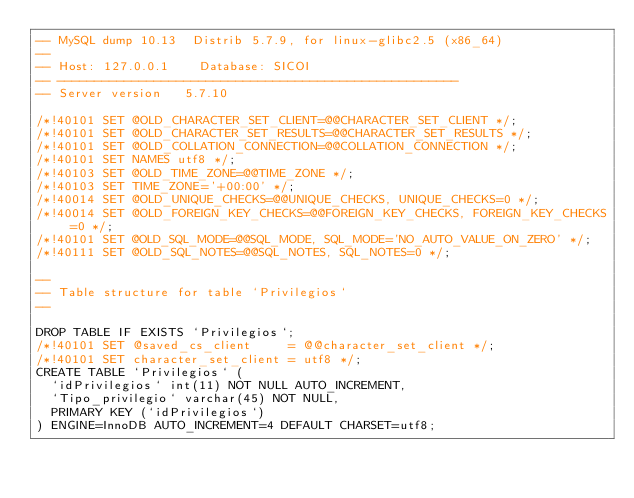Convert code to text. <code><loc_0><loc_0><loc_500><loc_500><_SQL_>-- MySQL dump 10.13  Distrib 5.7.9, for linux-glibc2.5 (x86_64)
--
-- Host: 127.0.0.1    Database: SICOI
-- ------------------------------------------------------
-- Server version	5.7.10

/*!40101 SET @OLD_CHARACTER_SET_CLIENT=@@CHARACTER_SET_CLIENT */;
/*!40101 SET @OLD_CHARACTER_SET_RESULTS=@@CHARACTER_SET_RESULTS */;
/*!40101 SET @OLD_COLLATION_CONNECTION=@@COLLATION_CONNECTION */;
/*!40101 SET NAMES utf8 */;
/*!40103 SET @OLD_TIME_ZONE=@@TIME_ZONE */;
/*!40103 SET TIME_ZONE='+00:00' */;
/*!40014 SET @OLD_UNIQUE_CHECKS=@@UNIQUE_CHECKS, UNIQUE_CHECKS=0 */;
/*!40014 SET @OLD_FOREIGN_KEY_CHECKS=@@FOREIGN_KEY_CHECKS, FOREIGN_KEY_CHECKS=0 */;
/*!40101 SET @OLD_SQL_MODE=@@SQL_MODE, SQL_MODE='NO_AUTO_VALUE_ON_ZERO' */;
/*!40111 SET @OLD_SQL_NOTES=@@SQL_NOTES, SQL_NOTES=0 */;

--
-- Table structure for table `Privilegios`
--

DROP TABLE IF EXISTS `Privilegios`;
/*!40101 SET @saved_cs_client     = @@character_set_client */;
/*!40101 SET character_set_client = utf8 */;
CREATE TABLE `Privilegios` (
  `idPrivilegios` int(11) NOT NULL AUTO_INCREMENT,
  `Tipo_privilegio` varchar(45) NOT NULL,
  PRIMARY KEY (`idPrivilegios`)
) ENGINE=InnoDB AUTO_INCREMENT=4 DEFAULT CHARSET=utf8;</code> 